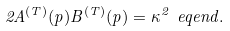<formula> <loc_0><loc_0><loc_500><loc_500>2 A ^ { ( T ) } ( p ) B ^ { ( T ) } ( p ) = \kappa ^ { 2 } \ e q e n d { . }</formula> 